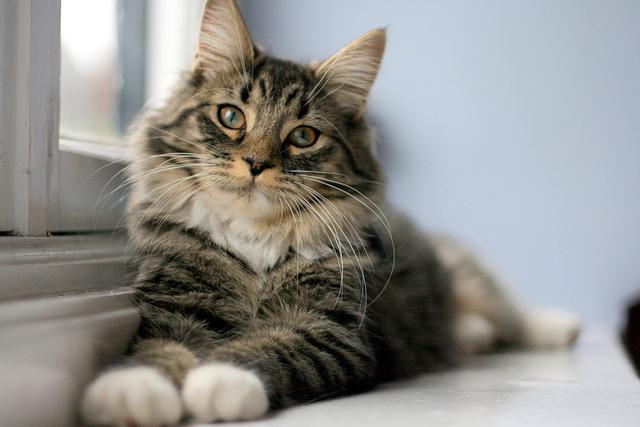What breed cat is this?
Answer briefly. Tabby. How many cats are there?
Quick response, please. 1. Is the cat awake?
Short answer required. Yes. What is the cat sitting on?
Keep it brief. Counter. 